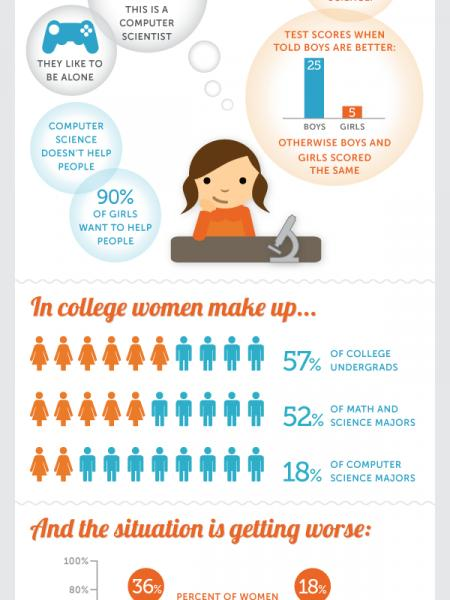Draw attention to some important aspects in this diagram. According to the given statistic, 48% of students who are pursuing majors in math and science are males. In a study of computer science majors, it was found that 82% of students who are pursuing this field of study are male. It is estimated that approximately 10% of girls do not want to help people. According to a recent survey, a majority of undergraduate college students are male, representing 43% of the total student population. 